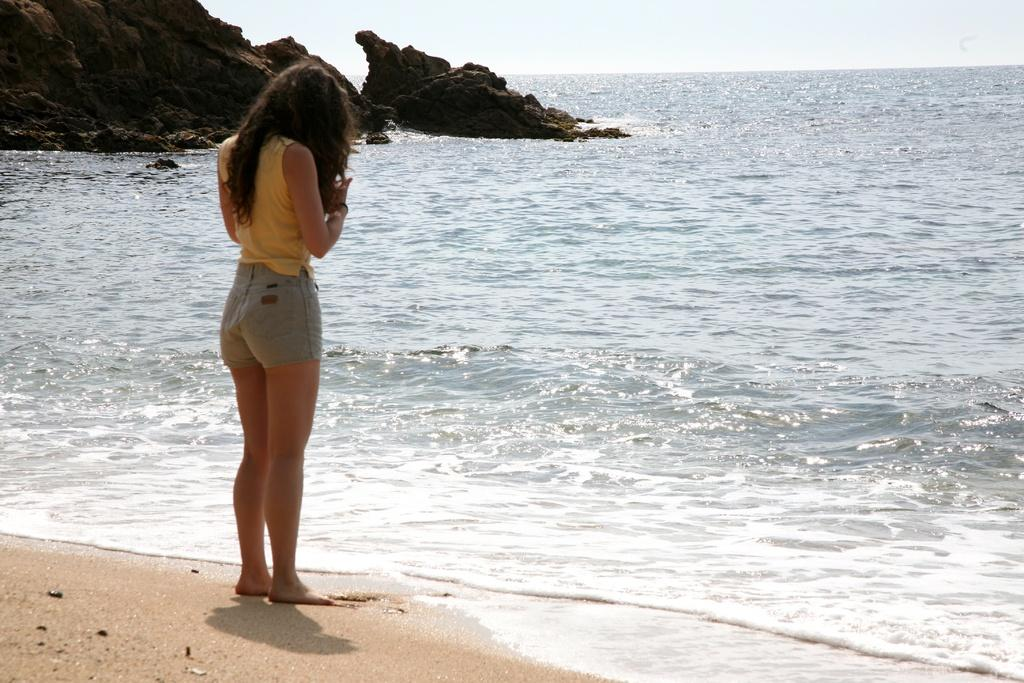What is the main subject of the image? There is a lady person in the image. What is the lady person wearing on her upper body? The lady person is wearing a yellow top. What is the lady person wearing on her lower body? The lady person is wearing jeans bottom. Where is the lady person standing in the image? The lady person is standing at the seashore. What can be seen in the background of the image? There is water, rocks, and a clear sky visible in the background of the image. What type of coat is the lady person wearing for her birthday celebration in the image? There is no coat or birthday celebration mentioned in the image. The lady person is wearing a yellow top and jeans bottom while standing at the seashore. 